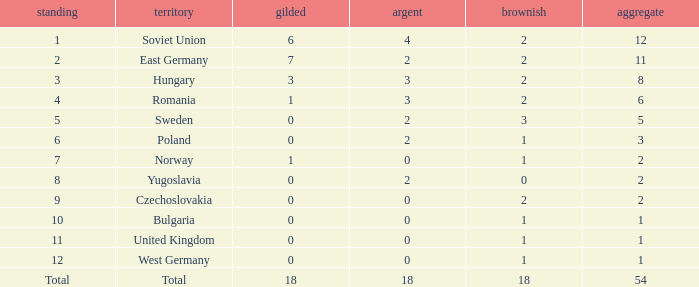What's the highest total of Romania when the bronze was less than 2? None. 